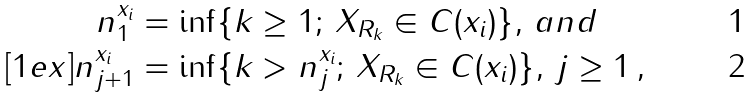Convert formula to latex. <formula><loc_0><loc_0><loc_500><loc_500>n ^ { x _ { i } } _ { 1 } & = \inf \{ k \geq 1 ; \, X _ { R _ { k } } \in C ( x _ { i } ) \} , \, a n d \\ [ 1 e x ] n ^ { x _ { i } } _ { j + 1 } & = \inf \{ k > n _ { j } ^ { x _ { i } } ; \, X _ { R _ { k } } \in C ( x _ { i } ) \} , \, j \geq 1 \, ,</formula> 